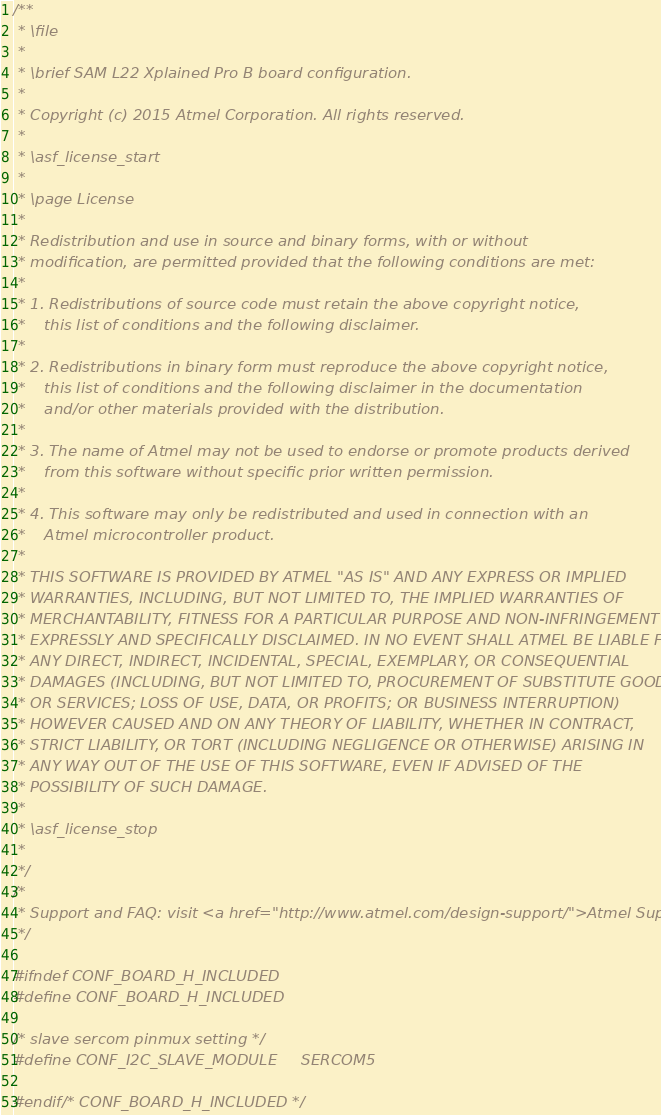<code> <loc_0><loc_0><loc_500><loc_500><_C_>/**
 * \file
 *
 * \brief SAM L22 Xplained Pro B board configuration.
 *
 * Copyright (c) 2015 Atmel Corporation. All rights reserved.
 *
 * \asf_license_start
 *
 * \page License
 *
 * Redistribution and use in source and binary forms, with or without
 * modification, are permitted provided that the following conditions are met:
 *
 * 1. Redistributions of source code must retain the above copyright notice,
 *    this list of conditions and the following disclaimer.
 *
 * 2. Redistributions in binary form must reproduce the above copyright notice,
 *    this list of conditions and the following disclaimer in the documentation
 *    and/or other materials provided with the distribution.
 *
 * 3. The name of Atmel may not be used to endorse or promote products derived
 *    from this software without specific prior written permission.
 *
 * 4. This software may only be redistributed and used in connection with an
 *    Atmel microcontroller product.
 *
 * THIS SOFTWARE IS PROVIDED BY ATMEL "AS IS" AND ANY EXPRESS OR IMPLIED
 * WARRANTIES, INCLUDING, BUT NOT LIMITED TO, THE IMPLIED WARRANTIES OF
 * MERCHANTABILITY, FITNESS FOR A PARTICULAR PURPOSE AND NON-INFRINGEMENT ARE
 * EXPRESSLY AND SPECIFICALLY DISCLAIMED. IN NO EVENT SHALL ATMEL BE LIABLE FOR
 * ANY DIRECT, INDIRECT, INCIDENTAL, SPECIAL, EXEMPLARY, OR CONSEQUENTIAL
 * DAMAGES (INCLUDING, BUT NOT LIMITED TO, PROCUREMENT OF SUBSTITUTE GOODS
 * OR SERVICES; LOSS OF USE, DATA, OR PROFITS; OR BUSINESS INTERRUPTION)
 * HOWEVER CAUSED AND ON ANY THEORY OF LIABILITY, WHETHER IN CONTRACT,
 * STRICT LIABILITY, OR TORT (INCLUDING NEGLIGENCE OR OTHERWISE) ARISING IN
 * ANY WAY OUT OF THE USE OF THIS SOFTWARE, EVEN IF ADVISED OF THE
 * POSSIBILITY OF SUCH DAMAGE.
 *
 * \asf_license_stop
 *
 */
/*
 * Support and FAQ: visit <a href="http://www.atmel.com/design-support/">Atmel Support</a>
 */

#ifndef CONF_BOARD_H_INCLUDED
#define CONF_BOARD_H_INCLUDED

/* slave sercom pinmux setting */
#define CONF_I2C_SLAVE_MODULE     SERCOM5

#endif /* CONF_BOARD_H_INCLUDED */
</code> 